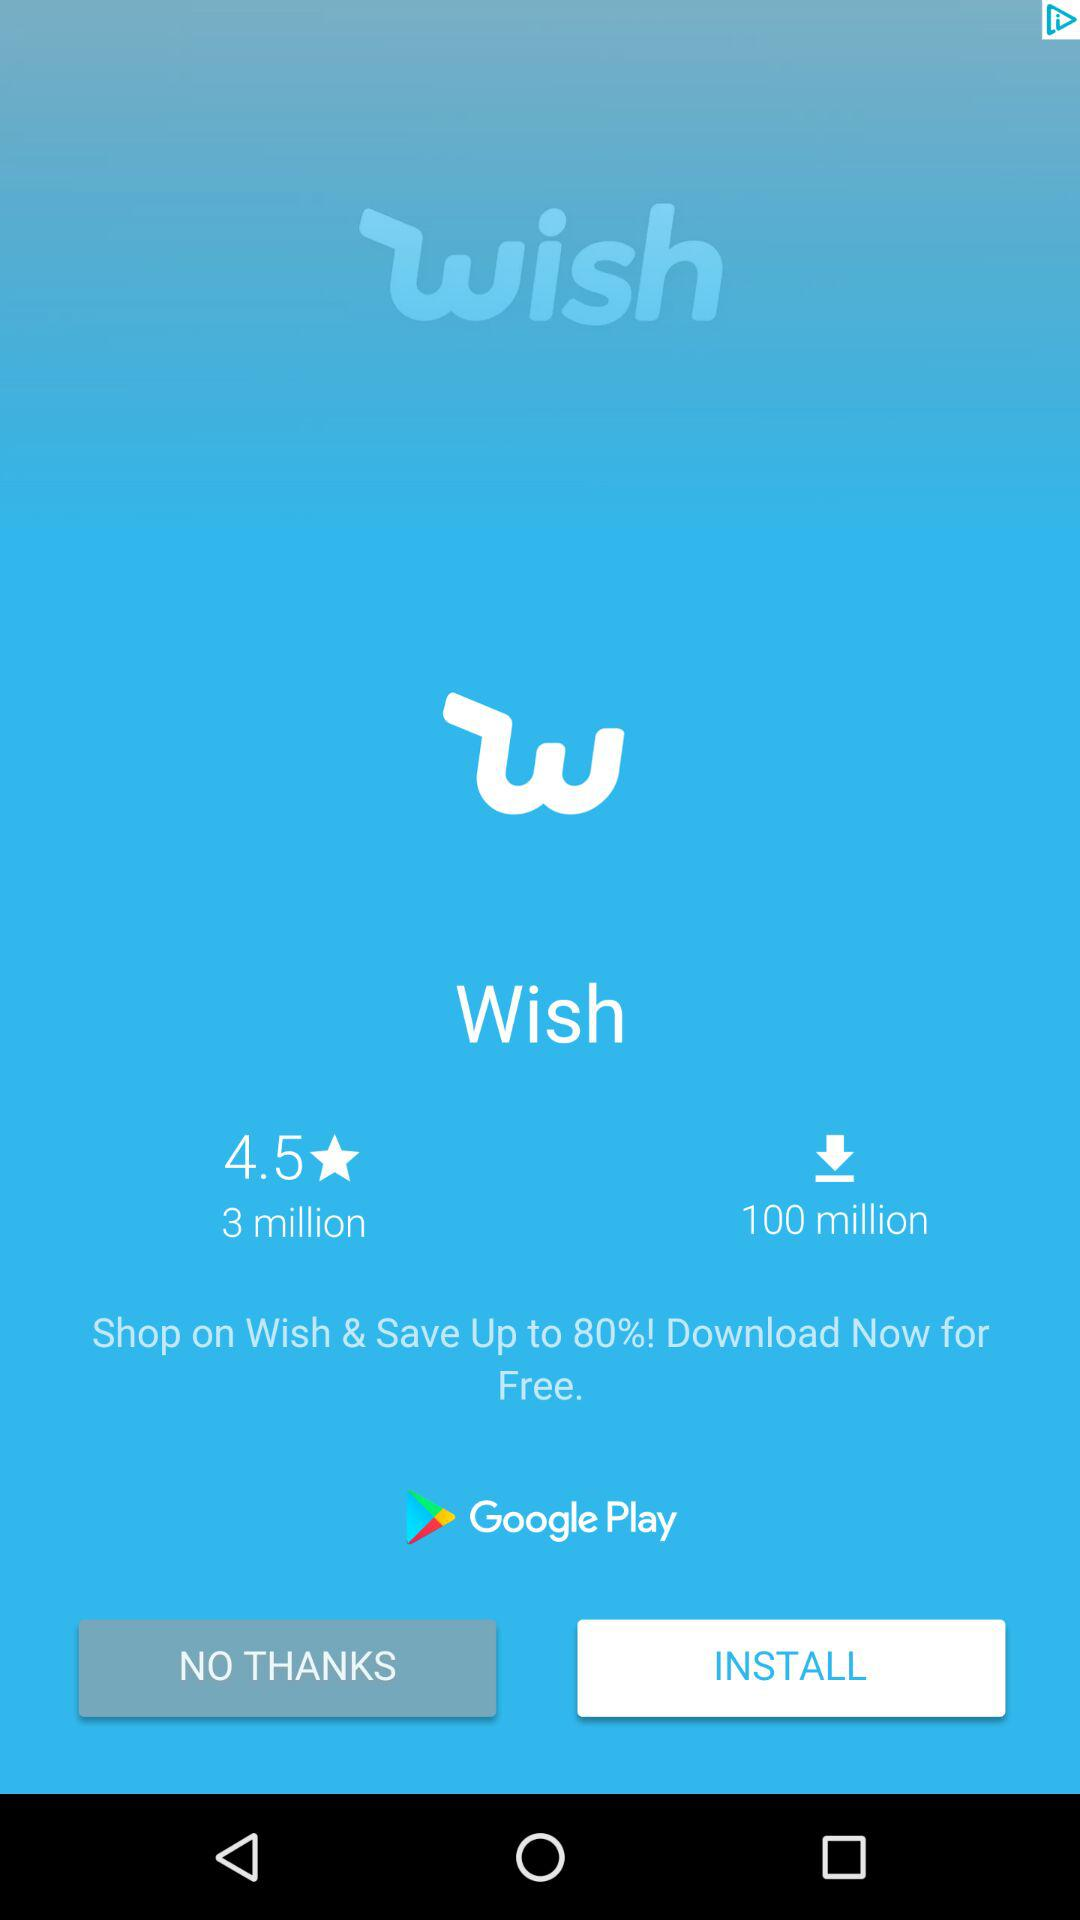How many more downloads does Wish have than reviews?
Answer the question using a single word or phrase. 97 million 